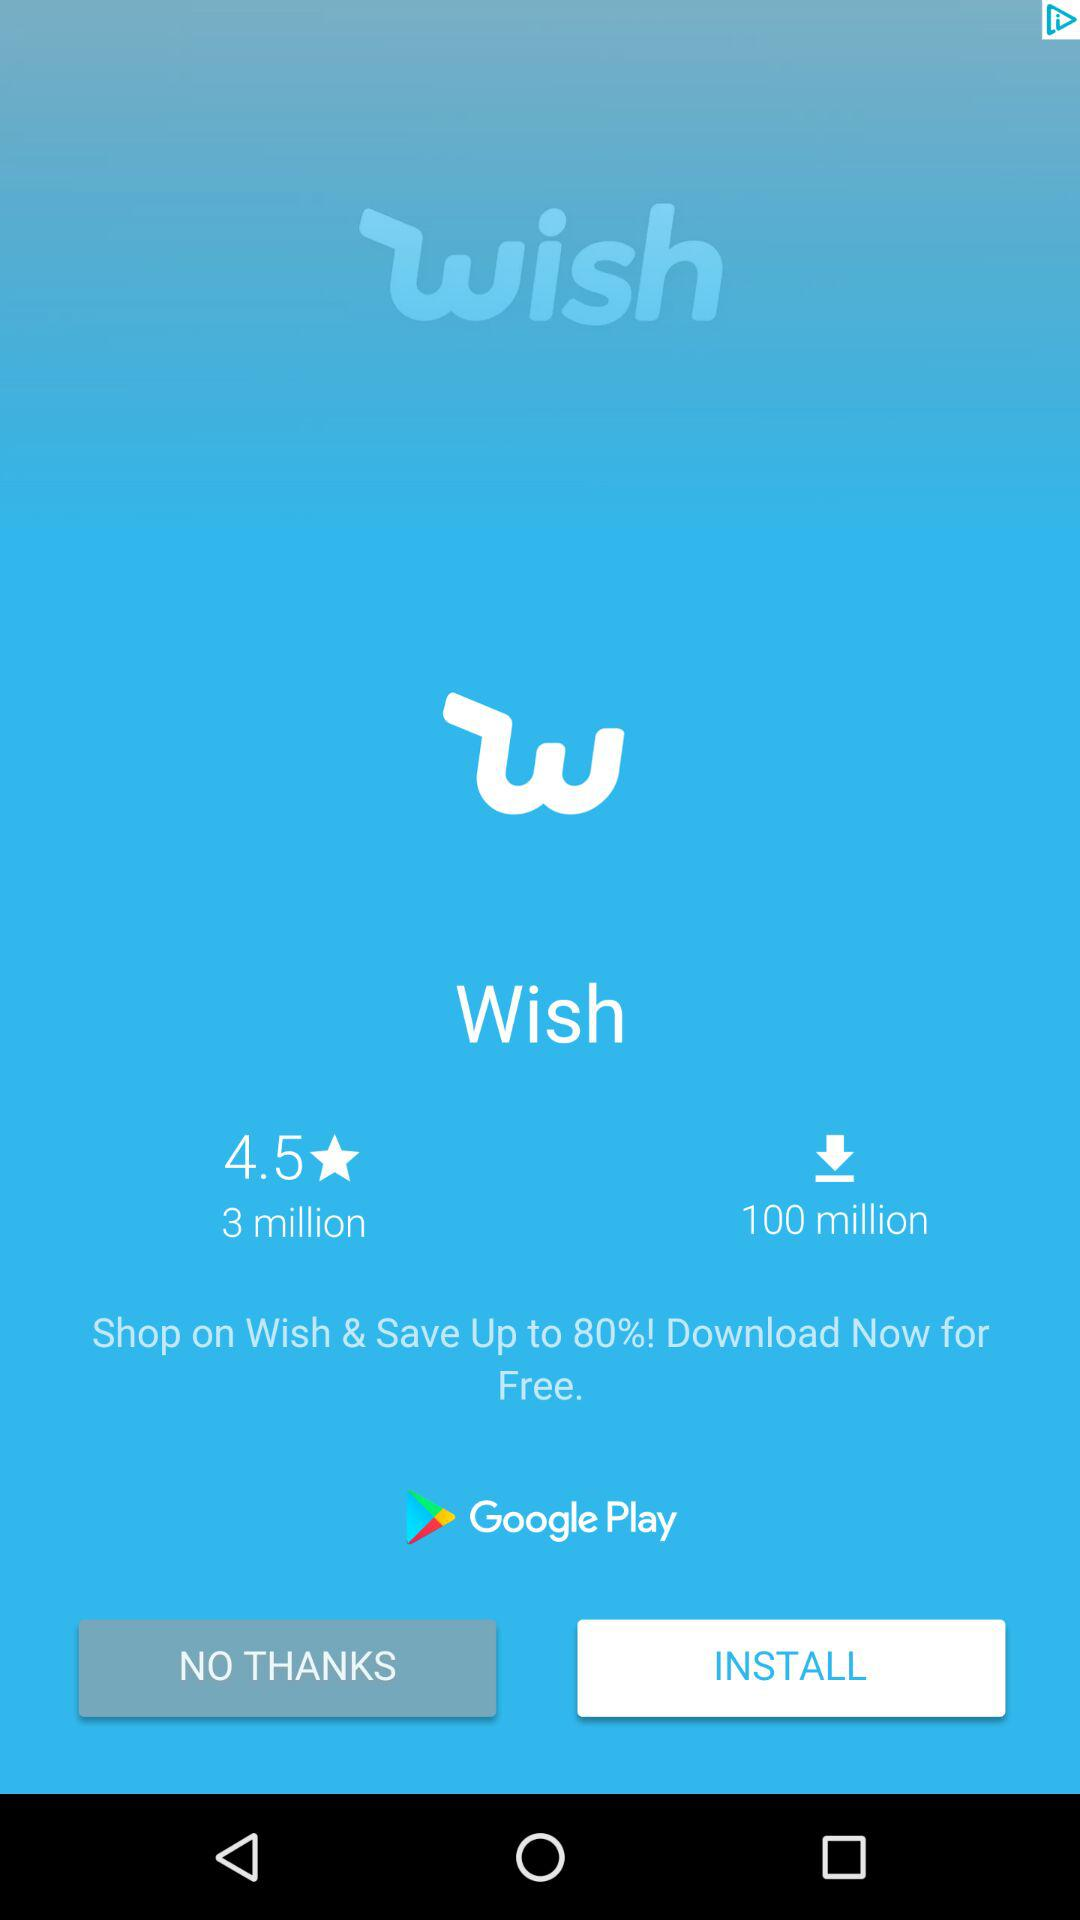How many more downloads does Wish have than reviews?
Answer the question using a single word or phrase. 97 million 